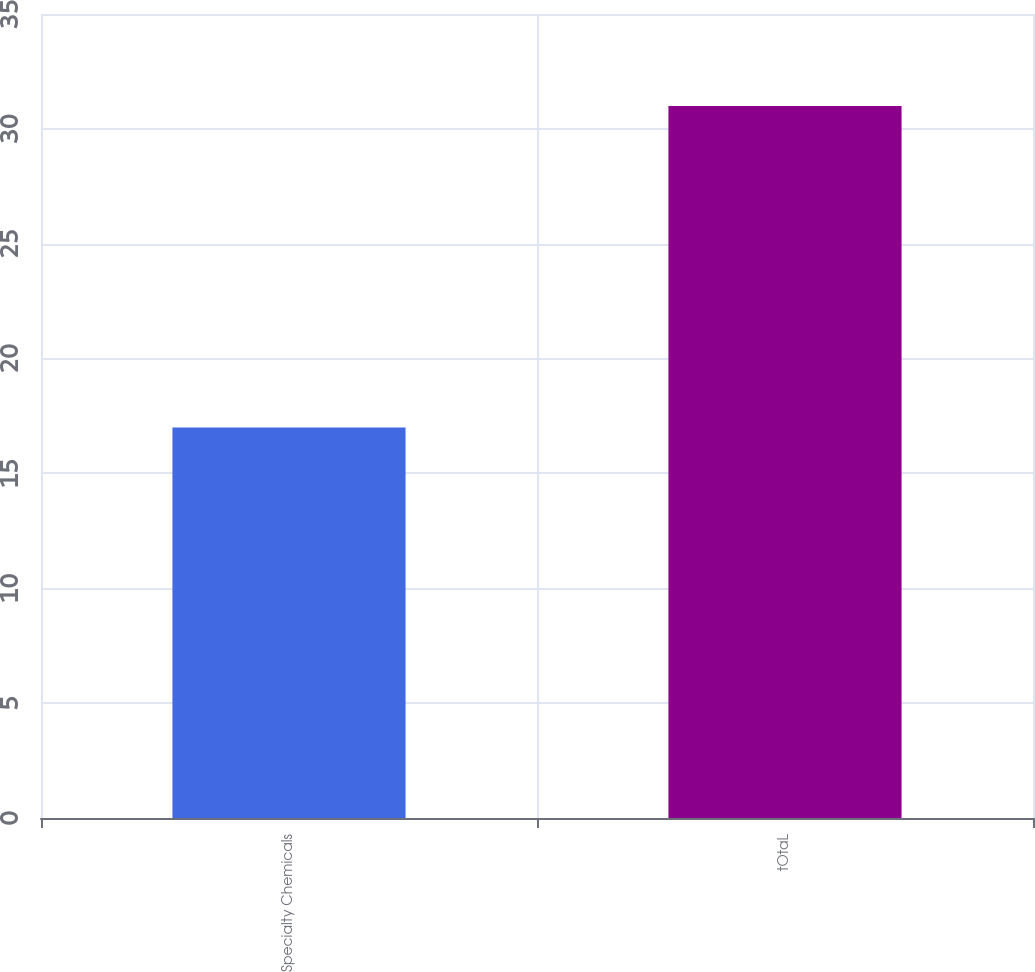Convert chart. <chart><loc_0><loc_0><loc_500><loc_500><bar_chart><fcel>Specialty Chemicals<fcel>tOtaL<nl><fcel>17<fcel>31<nl></chart> 